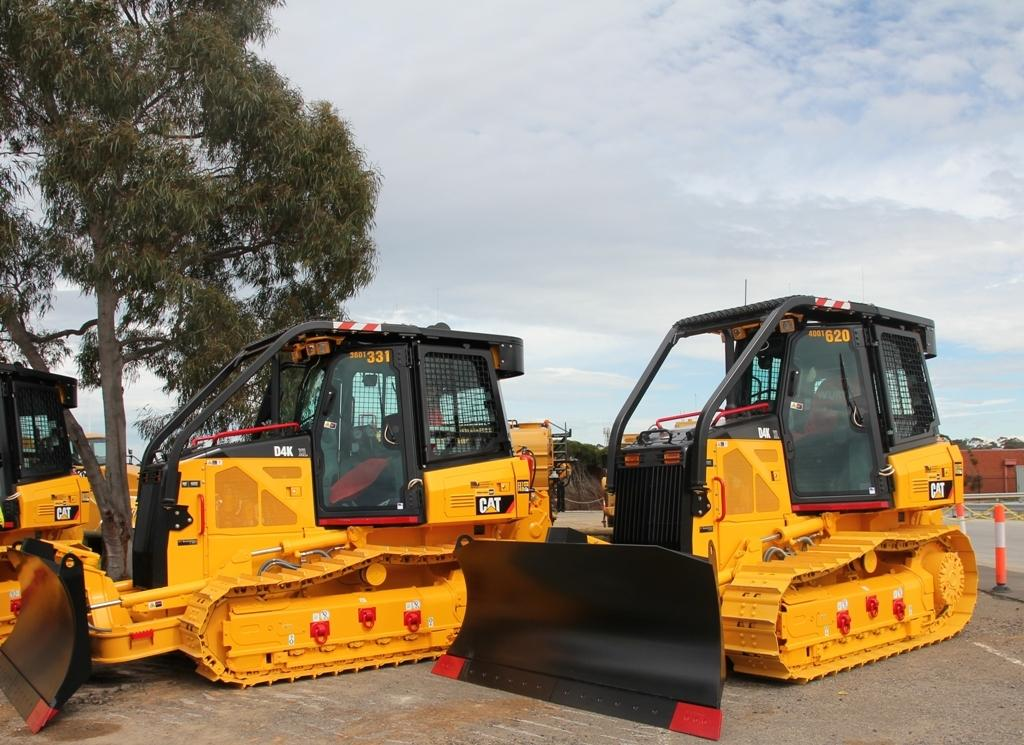What type of machinery can be seen on the ground in the image? There are bulldozers on the ground in the image. What is located on the left side of the image? There is a tree on the left side of the image. What is visible at the top of the image? The sky is visible at the top of the image. What can be observed in the sky? Clouds are present in the sky. How many legs does the tree have in the image? Trees do not have legs; they have trunks and branches. --- Facts: 1. There is a car in the image. 2. The car is red. 3. The car has four wheels. 4. There is a road in the image. 5. The road is paved. Absurd Topics: ocean, dance, feather Conversation: What type of vehicle is in the image? There is a car in the image. What color is the car? The car is red. How many wheels does the car have? The car has four wheels. What is the surface of the road in the image? The road is paved. Reasoning: Let's think step by step in order to produce the conversation. We start by identifying the main subject in the image, which is the car. Then, we expand the conversation to include other details about the car, such as its color and the number of wheels. Finally, we describe the road in the image. Each question is designed to elicit a specific detail about the image that is known from the provided facts. Absurd Question/Answer: How many feathers can be seen on the car in the image? There are no feathers present in the image. 